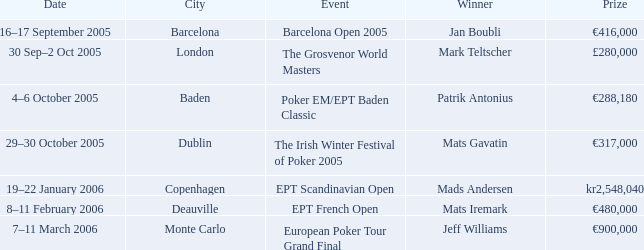In which city did patrik antonius achieve victory? Baden. 